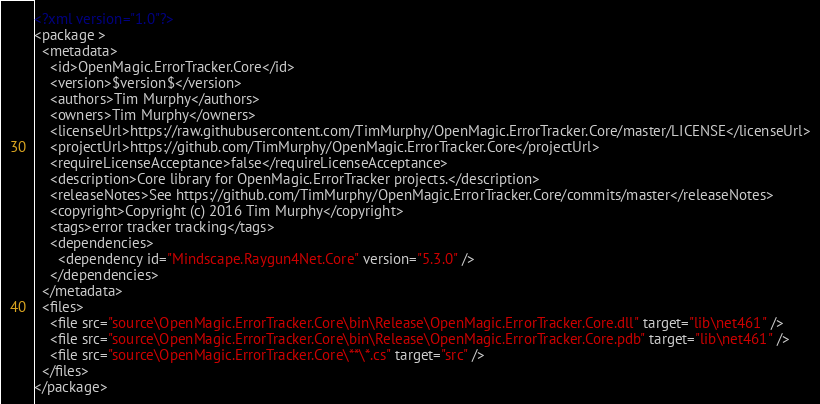Convert code to text. <code><loc_0><loc_0><loc_500><loc_500><_XML_><?xml version="1.0"?>
<package >
  <metadata>
    <id>OpenMagic.ErrorTracker.Core</id>
    <version>$version$</version>
    <authors>Tim Murphy</authors>
    <owners>Tim Murphy</owners>
    <licenseUrl>https://raw.githubusercontent.com/TimMurphy/OpenMagic.ErrorTracker.Core/master/LICENSE</licenseUrl>
    <projectUrl>https://github.com/TimMurphy/OpenMagic.ErrorTracker.Core</projectUrl>
    <requireLicenseAcceptance>false</requireLicenseAcceptance>
    <description>Core library for OpenMagic.ErrorTracker projects.</description>
    <releaseNotes>See https://github.com/TimMurphy/OpenMagic.ErrorTracker.Core/commits/master</releaseNotes>
    <copyright>Copyright (c) 2016 Tim Murphy</copyright>
    <tags>error tracker tracking</tags>
    <dependencies>
      <dependency id="Mindscape.Raygun4Net.Core" version="5.3.0" />
    </dependencies>
  </metadata>
  <files>
    <file src="source\OpenMagic.ErrorTracker.Core\bin\Release\OpenMagic.ErrorTracker.Core.dll" target="lib\net461" />
    <file src="source\OpenMagic.ErrorTracker.Core\bin\Release\OpenMagic.ErrorTracker.Core.pdb" target="lib\net461" />
    <file src="source\OpenMagic.ErrorTracker.Core\**\*.cs" target="src" />
  </files>
</package></code> 